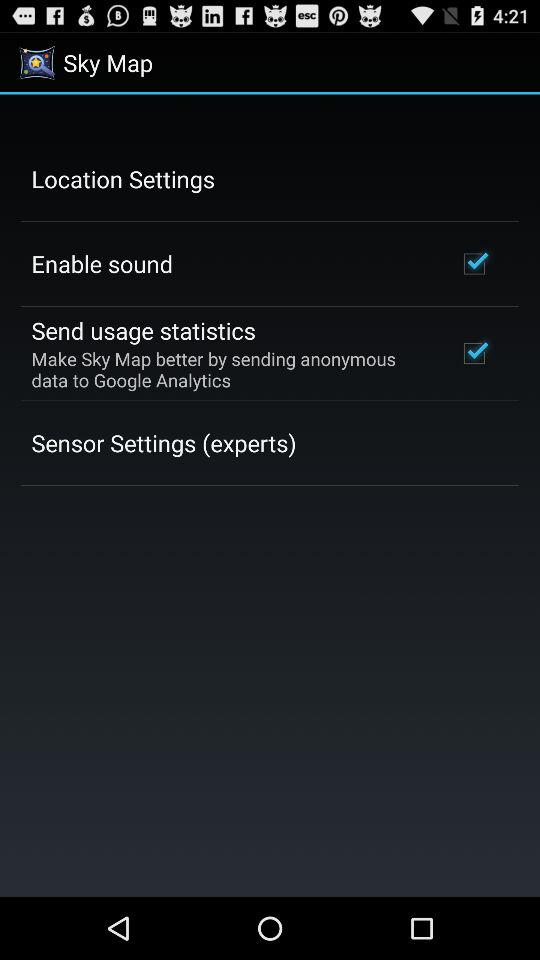What is the application name? The application name is "Sky Map". 